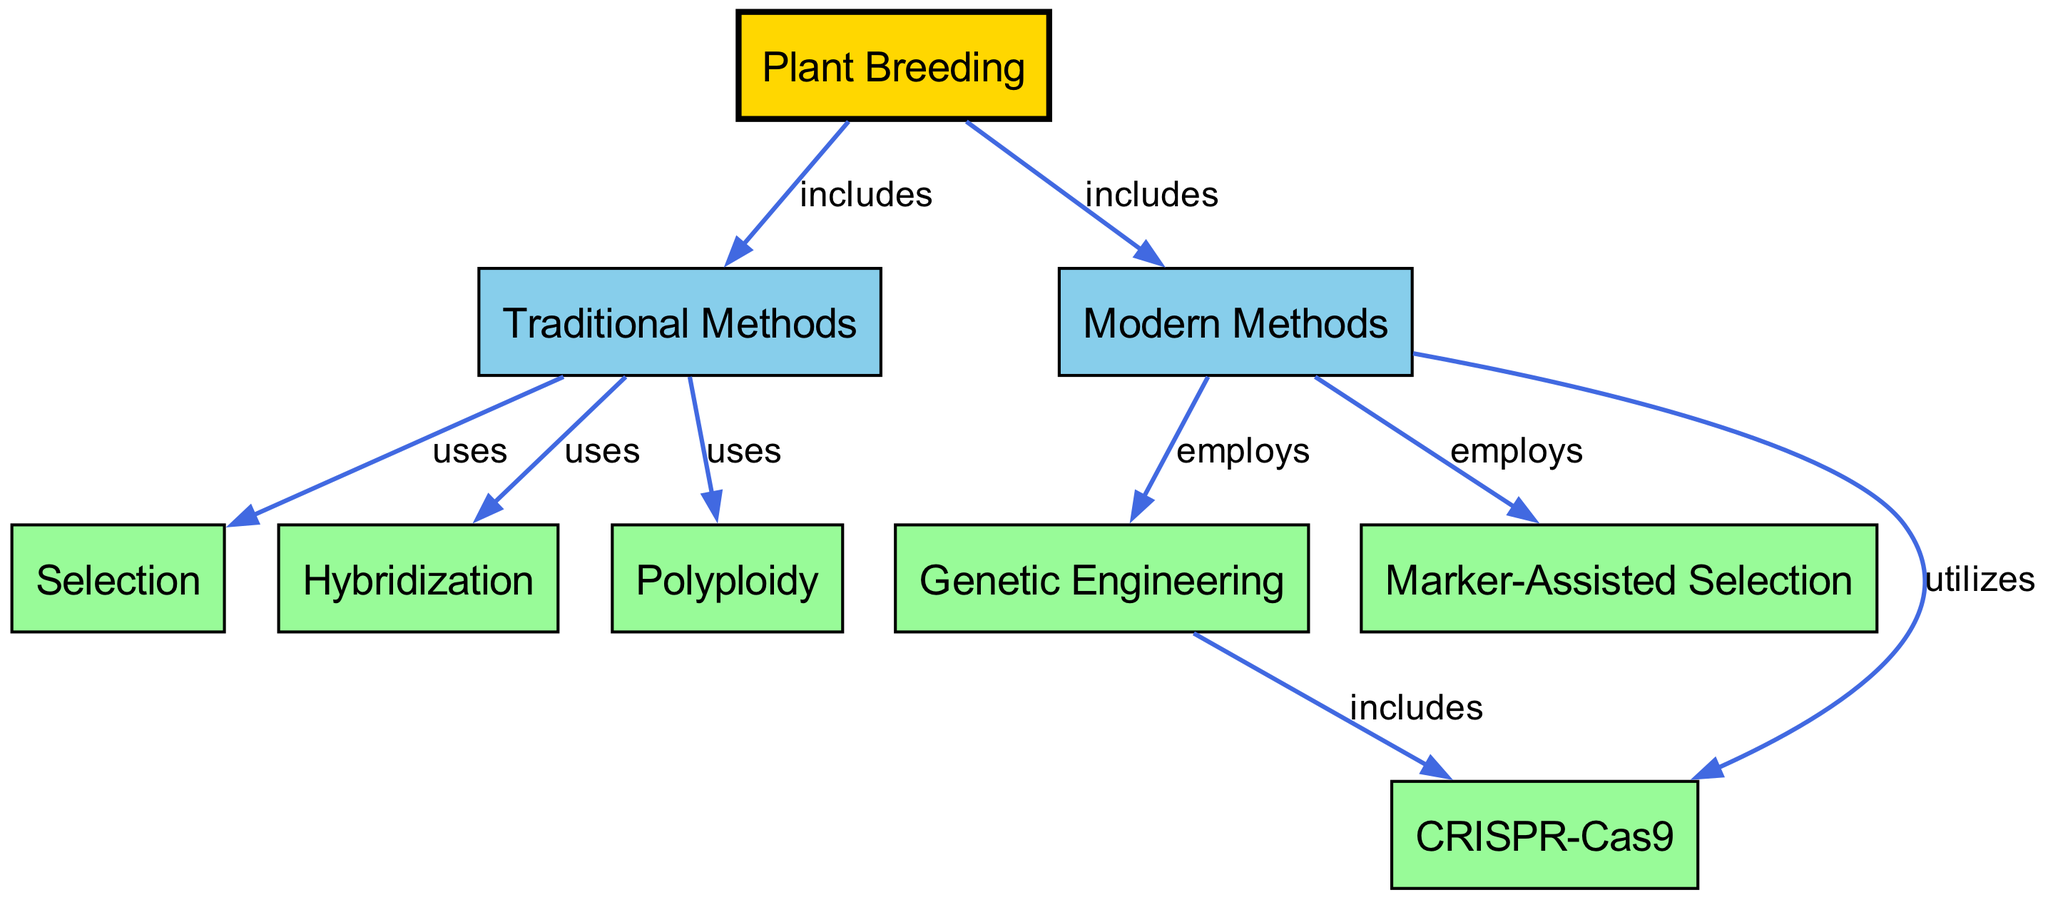What are the two main categories of methods in plant breeding? The diagram shows two main categories under the "Plant Breeding" node: "Traditional Methods" and "Modern Methods". These are directly connected to the "Plant Breeding" node with the label "includes".
Answer: Traditional Methods, Modern Methods How many techniques are listed under Traditional Methods? Under the "Traditional Methods" node, there are three techniques connected to it: "Selection", "Hybridization", and "Polyploidy". Counting these gives a total of three techniques.
Answer: 3 What technique does Hybridization belong to? The "Hybridization" node is connected to the "Traditional Methods" node with the label "uses". This indicates that Hybridization is a technique utilized within Traditional Methods.
Answer: Traditional Methods Which modern method includes CRISPR-Cas9? The "CRISPR-Cas9" node is connected to the "Genetic Engineering" node with the label "includes". Therefore, CRISPR-Cas9 is included in the Genetic Engineering method.
Answer: Genetic Engineering What is the relationship between Modern Methods and Marker-Assisted Selection? The "Marker-Assisted Selection" node is connected to the "Modern Methods" node with the label "employs", indicating that Marker-Assisted Selection is a technique used within Modern Methods.
Answer: employs Which traditional method utilizes Polyploidy? The "Polyploidy" node is connected to the "Traditional Methods" node with the label "uses", indicating that Polyploidy is a method applied within Traditional Methods in plant breeding.
Answer: Traditional Methods How many edges connect to the Genetic Engineering node? The "Genetic Engineering" node has two edges connecting it: one to "CRISPR-Cas9" and one to "Marker-Assisted Selection". Thus, there are two edges connected to it.
Answer: 2 Which modern method is related to both Genetic Engineering and Marker-Assisted Selection? The "Modern Methods" node includes both "Genetic Engineering" and "Marker-Assisted Selection" techniques as indicated by their direct connections with respective labels. Given that both techniques are associated with "Modern Methods", the answer is Modern Methods.
Answer: Modern Methods 